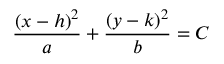<formula> <loc_0><loc_0><loc_500><loc_500>\frac { ( x - h ) ^ { 2 } } { a } + \frac { ( y - k ) ^ { 2 } } { b } = C</formula> 